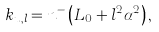Convert formula to latex. <formula><loc_0><loc_0><loc_500><loc_500>k _ { u , l } = n ^ { - } \left ( L _ { 0 } + l ^ { 2 } \alpha ^ { 2 } \right ) ,</formula> 